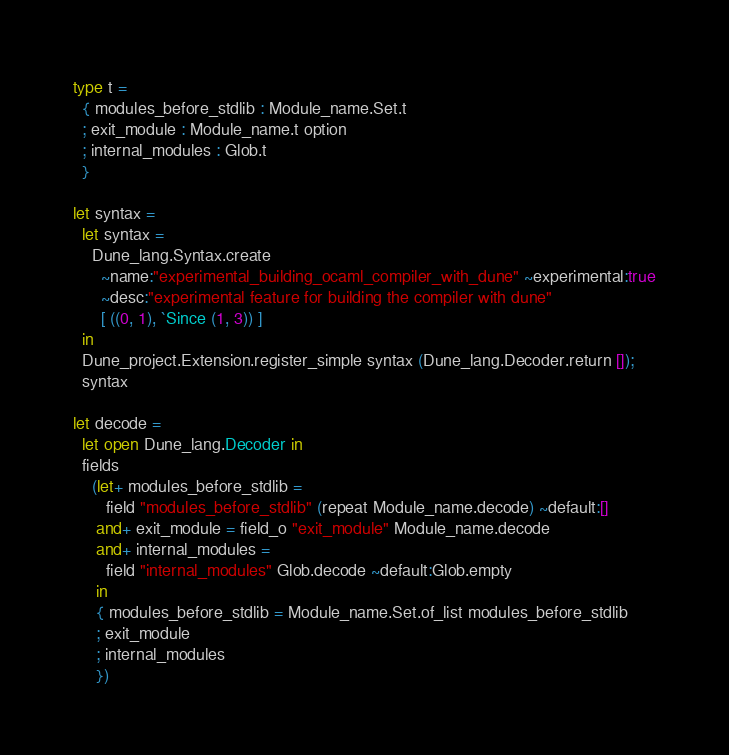<code> <loc_0><loc_0><loc_500><loc_500><_OCaml_>type t =
  { modules_before_stdlib : Module_name.Set.t
  ; exit_module : Module_name.t option
  ; internal_modules : Glob.t
  }

let syntax =
  let syntax =
    Dune_lang.Syntax.create
      ~name:"experimental_building_ocaml_compiler_with_dune" ~experimental:true
      ~desc:"experimental feature for building the compiler with dune"
      [ ((0, 1), `Since (1, 3)) ]
  in
  Dune_project.Extension.register_simple syntax (Dune_lang.Decoder.return []);
  syntax

let decode =
  let open Dune_lang.Decoder in
  fields
    (let+ modules_before_stdlib =
       field "modules_before_stdlib" (repeat Module_name.decode) ~default:[]
     and+ exit_module = field_o "exit_module" Module_name.decode
     and+ internal_modules =
       field "internal_modules" Glob.decode ~default:Glob.empty
     in
     { modules_before_stdlib = Module_name.Set.of_list modules_before_stdlib
     ; exit_module
     ; internal_modules
     })
</code> 